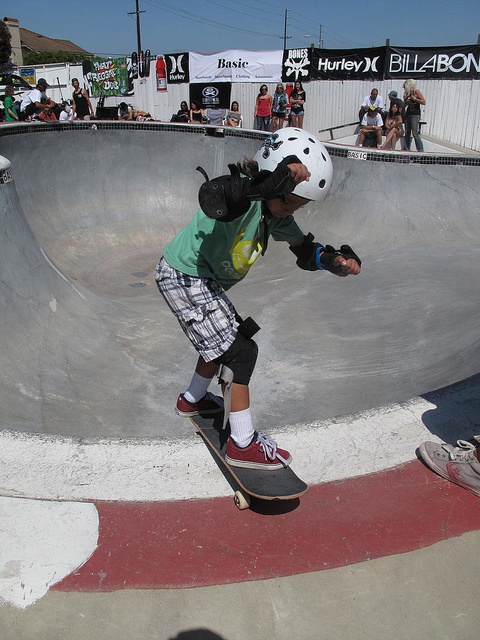Describe the objects in this image and their specific colors. I can see people in gray, black, darkgray, and lightgray tones, skateboard in gray and black tones, people in gray, darkgray, and black tones, people in gray, black, and darkgray tones, and people in gray, black, darkgray, and maroon tones in this image. 